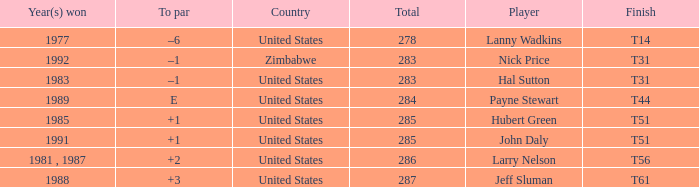What is Year(s) Won, when Finish is "T31", and when Player is "Nick Price"? 1992.0. 